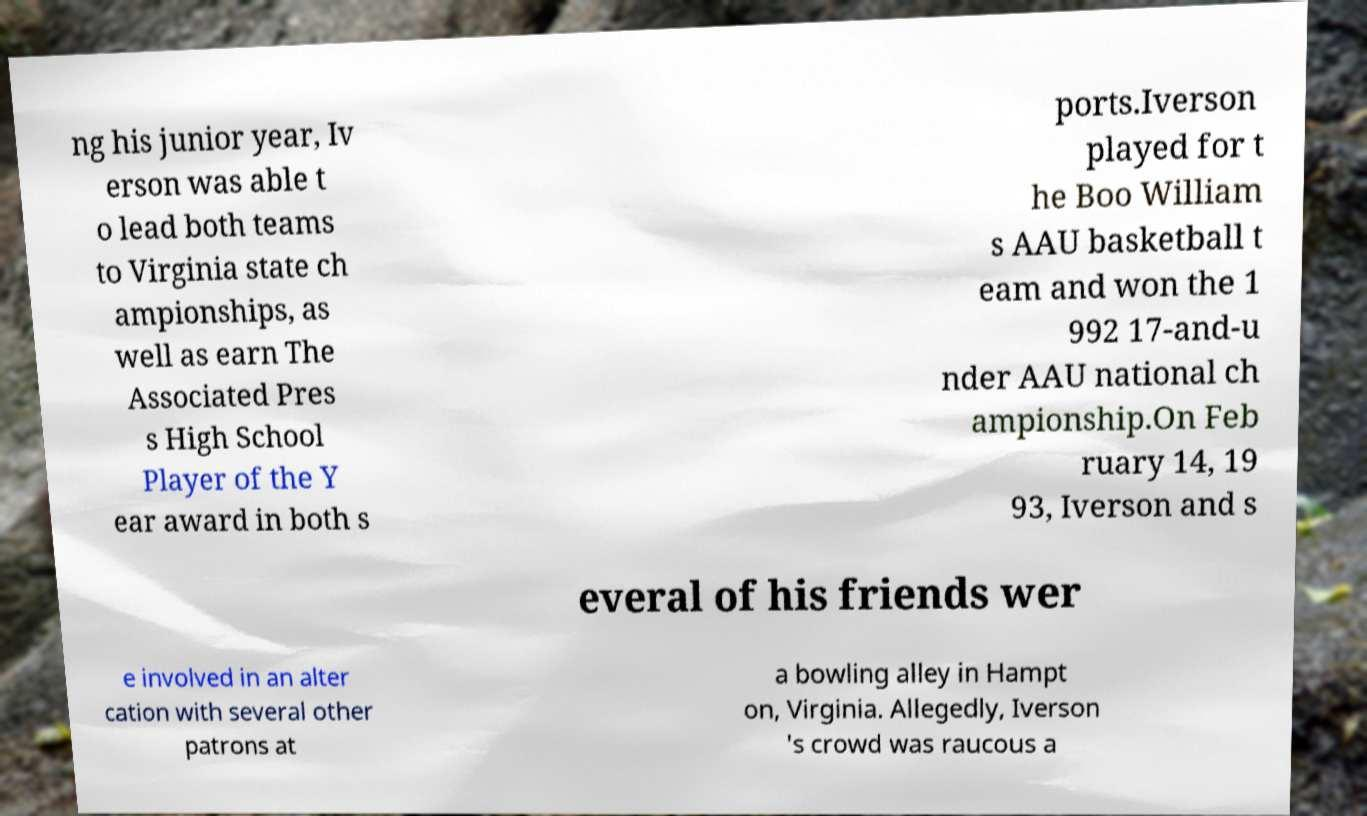There's text embedded in this image that I need extracted. Can you transcribe it verbatim? ng his junior year, Iv erson was able t o lead both teams to Virginia state ch ampionships, as well as earn The Associated Pres s High School Player of the Y ear award in both s ports.Iverson played for t he Boo William s AAU basketball t eam and won the 1 992 17-and-u nder AAU national ch ampionship.On Feb ruary 14, 19 93, Iverson and s everal of his friends wer e involved in an alter cation with several other patrons at a bowling alley in Hampt on, Virginia. Allegedly, Iverson 's crowd was raucous a 